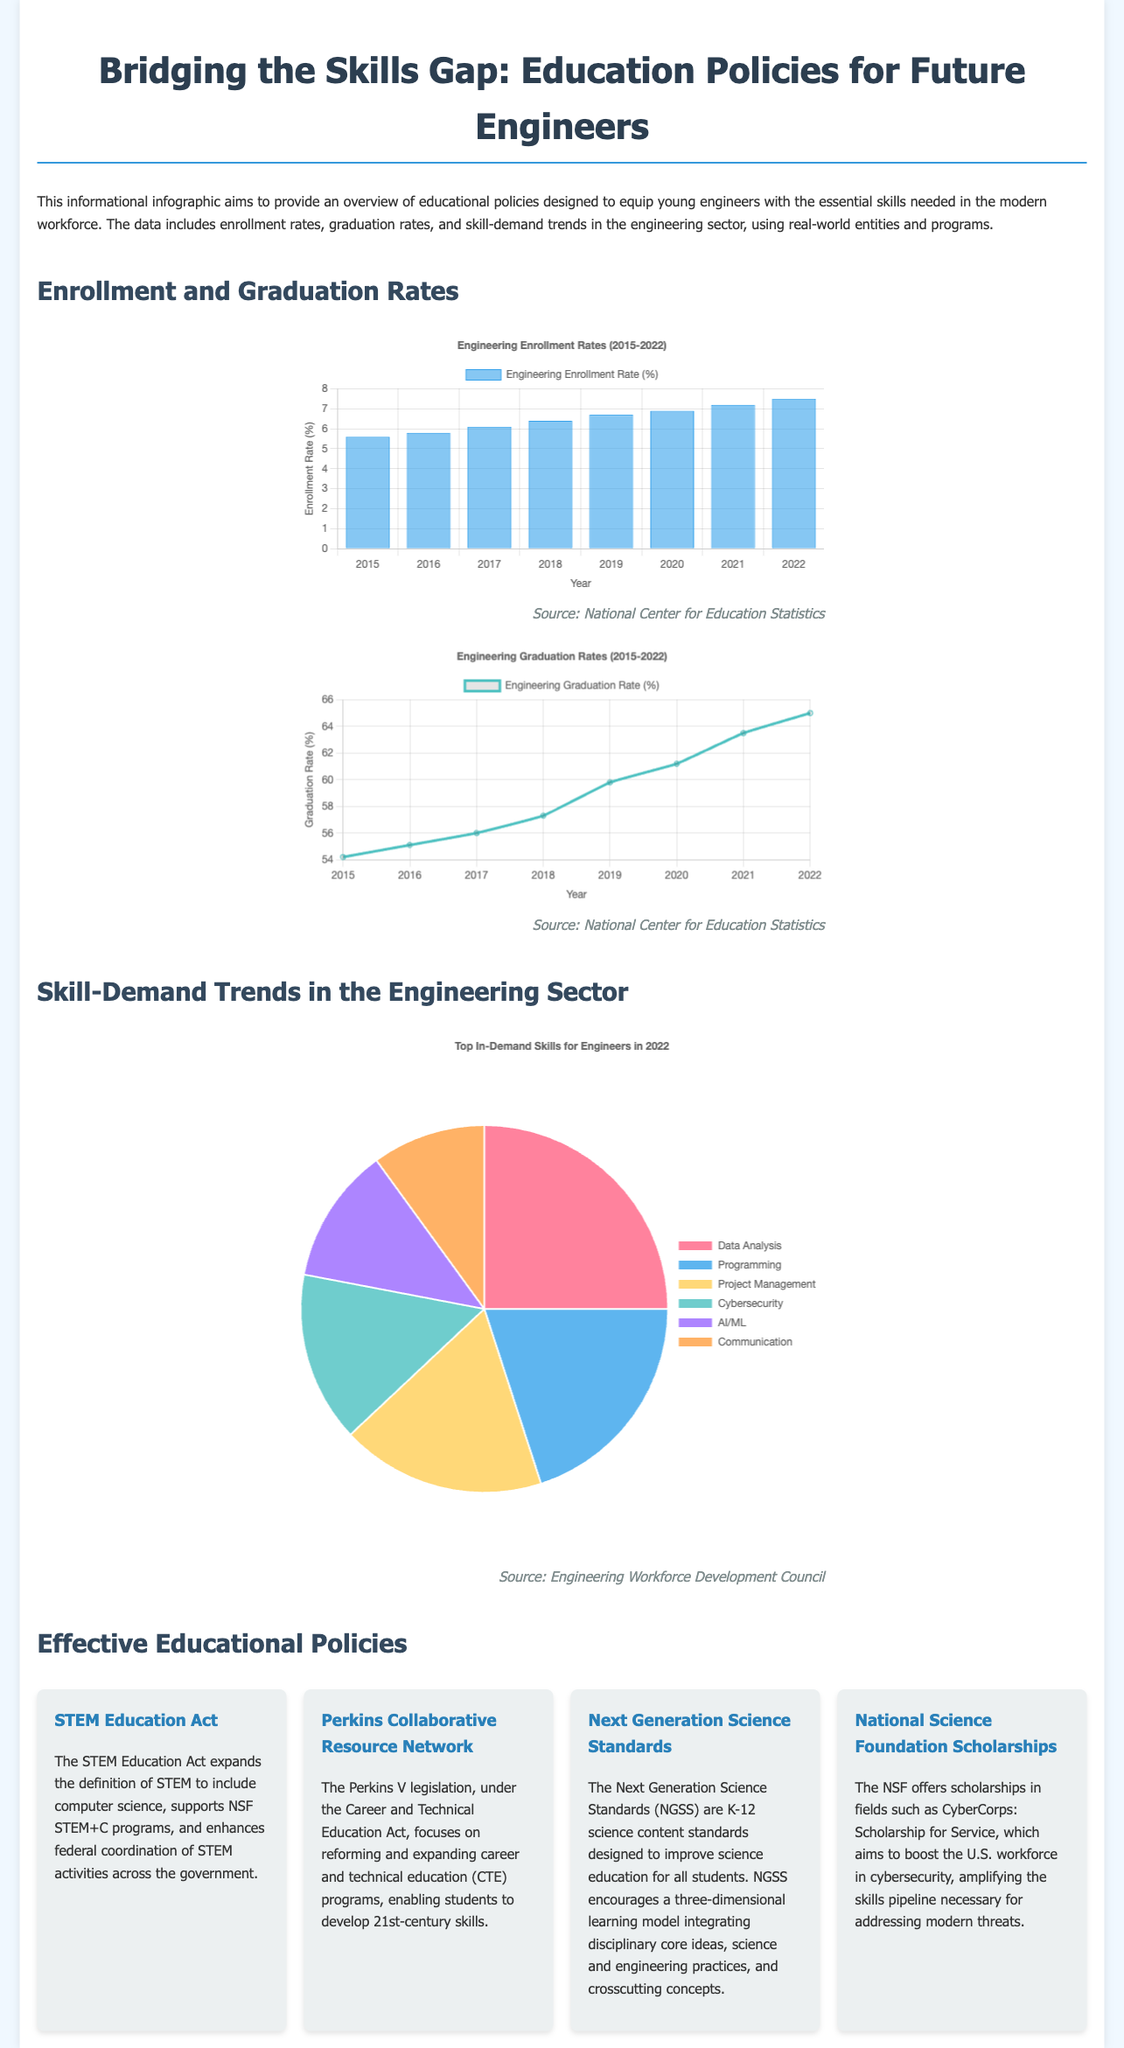What was the enrollment rate for engineering in 2022? The enrollment rate for engineering in 2022 was presented as 7.5% in the enrollment chart.
Answer: 7.5% What is the graduation rate for engineering in 2019? The graduation rate for engineering in 2019 was given as 59.8% in the graduation chart.
Answer: 59.8% Which policy focuses on expanding career and technical education programs? The policy that focuses on expanding career and technical education programs is identified as Perkins Collaborative Resource Network in the policy section.
Answer: Perkins Collaborative Resource Network What skill has the highest demand among engineers according to the skill demand chart? The skill with the highest demand shown in the skill demand chart is Data Analysis.
Answer: Data Analysis What trend does the engineering graduation rate show from 2015 to 2022? The trend indicates a general increase in the graduation rate for engineering from 2015 to 2022, as seen in the chart data.
Answer: Increase How many skills are listed in the skill demand chart? The skill demand chart lists a total of six different skills that are in demand for engineers.
Answer: Six What educational act expands the definition of STEM? The STEM Education Act is identified in the policy section as the act that expands the definition of STEM.
Answer: STEM Education Act What year shows the lowest engineering graduation rate in the chart? The year 2015 shows the lowest engineering graduation rate in the graduation chart, which is 54.2%.
Answer: 2015 